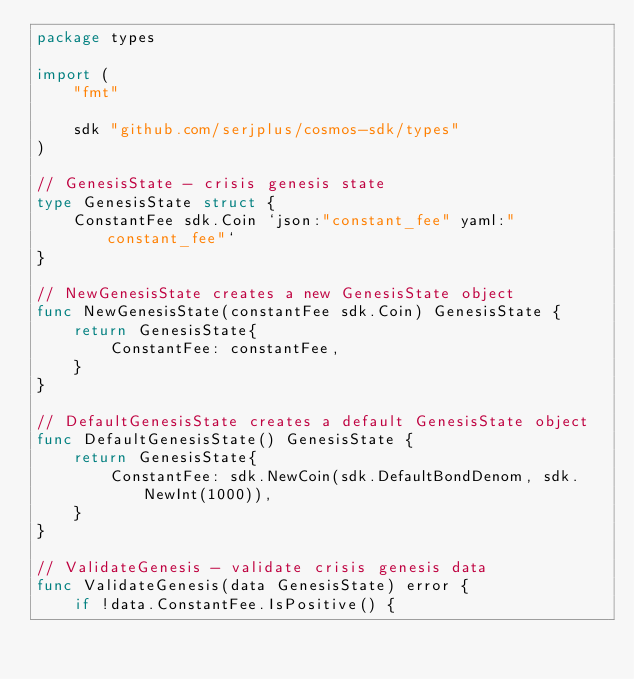Convert code to text. <code><loc_0><loc_0><loc_500><loc_500><_Go_>package types

import (
	"fmt"

	sdk "github.com/serjplus/cosmos-sdk/types"
)

// GenesisState - crisis genesis state
type GenesisState struct {
	ConstantFee sdk.Coin `json:"constant_fee" yaml:"constant_fee"`
}

// NewGenesisState creates a new GenesisState object
func NewGenesisState(constantFee sdk.Coin) GenesisState {
	return GenesisState{
		ConstantFee: constantFee,
	}
}

// DefaultGenesisState creates a default GenesisState object
func DefaultGenesisState() GenesisState {
	return GenesisState{
		ConstantFee: sdk.NewCoin(sdk.DefaultBondDenom, sdk.NewInt(1000)),
	}
}

// ValidateGenesis - validate crisis genesis data
func ValidateGenesis(data GenesisState) error {
	if !data.ConstantFee.IsPositive() {</code> 